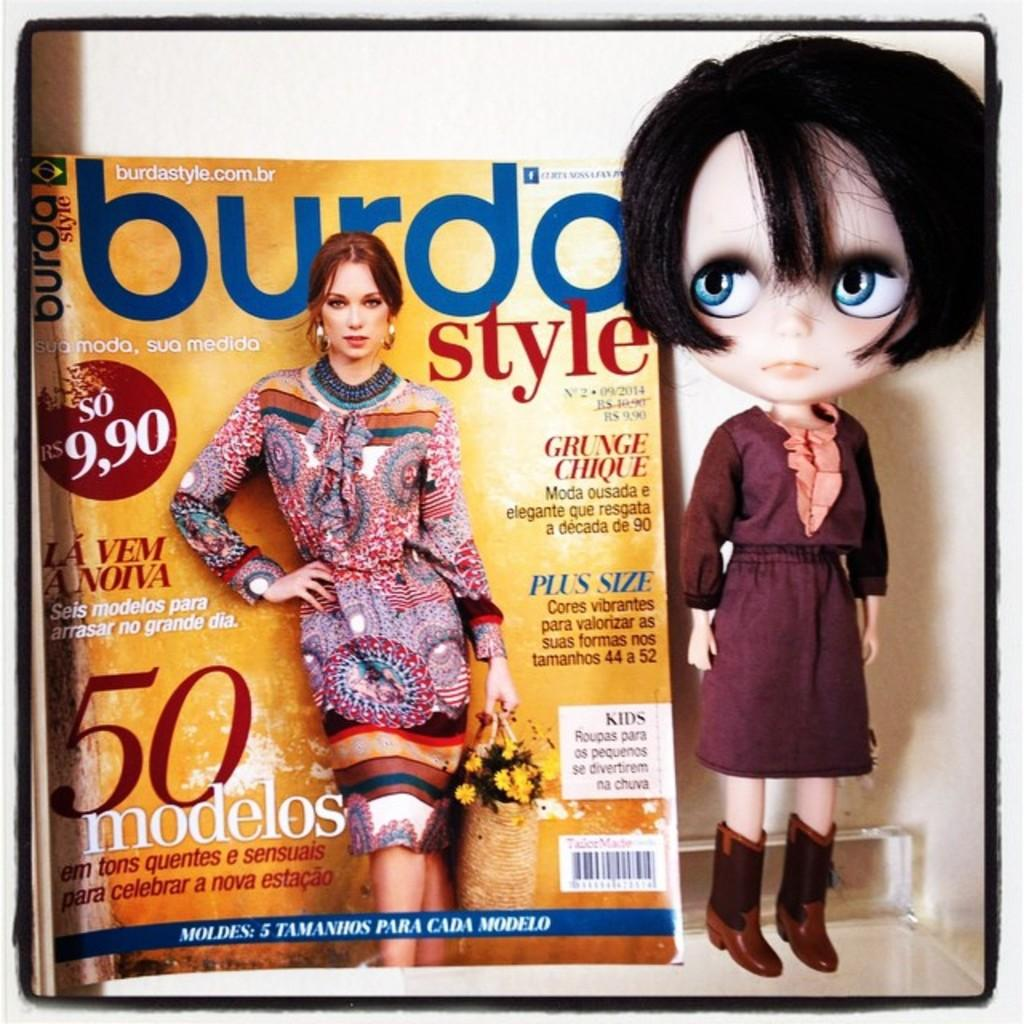What object can be seen in the image related to reading or learning? There is a book in the image. What other item can be seen in the image related to toys or play? There is a doll in the image. Where are the book and the doll located in the image? Both the book and the doll are placed in a shelf. What type of toothpaste is visible on the shelf in the image? There is no toothpaste present in the image. What color is the gold item on the shelf in the image? There is no gold item present in the image. 